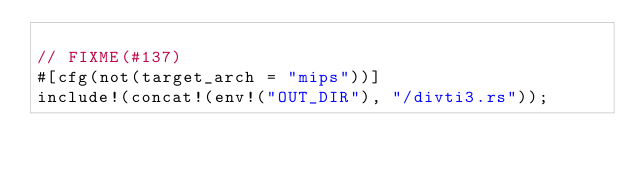<code> <loc_0><loc_0><loc_500><loc_500><_Rust_>
// FIXME(#137)
#[cfg(not(target_arch = "mips"))]
include!(concat!(env!("OUT_DIR"), "/divti3.rs"));
</code> 